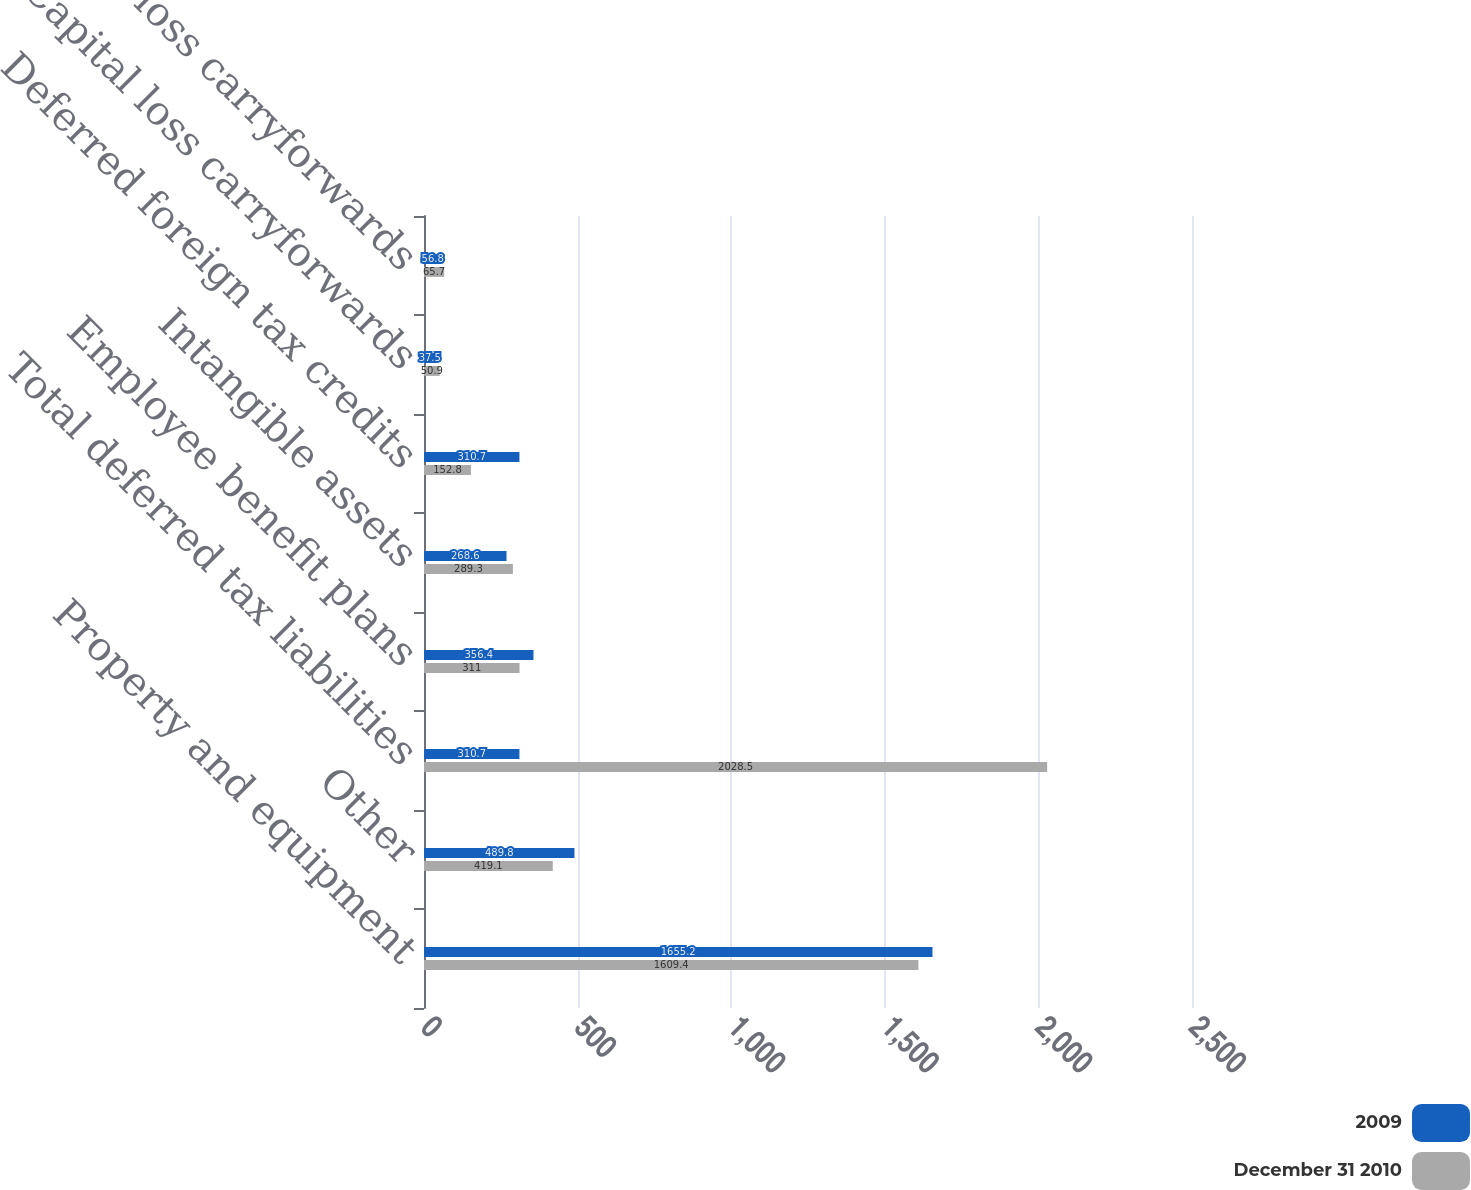<chart> <loc_0><loc_0><loc_500><loc_500><stacked_bar_chart><ecel><fcel>Property and equipment<fcel>Other<fcel>Total deferred tax liabilities<fcel>Employee benefit plans<fcel>Intangible assets<fcel>Deferred foreign tax credits<fcel>Capital loss carryforwards<fcel>Operating loss carryforwards<nl><fcel>2009<fcel>1655.2<fcel>489.8<fcel>310.7<fcel>356.4<fcel>268.6<fcel>310.7<fcel>37.5<fcel>56.8<nl><fcel>December 31 2010<fcel>1609.4<fcel>419.1<fcel>2028.5<fcel>311<fcel>289.3<fcel>152.8<fcel>50.9<fcel>65.7<nl></chart> 